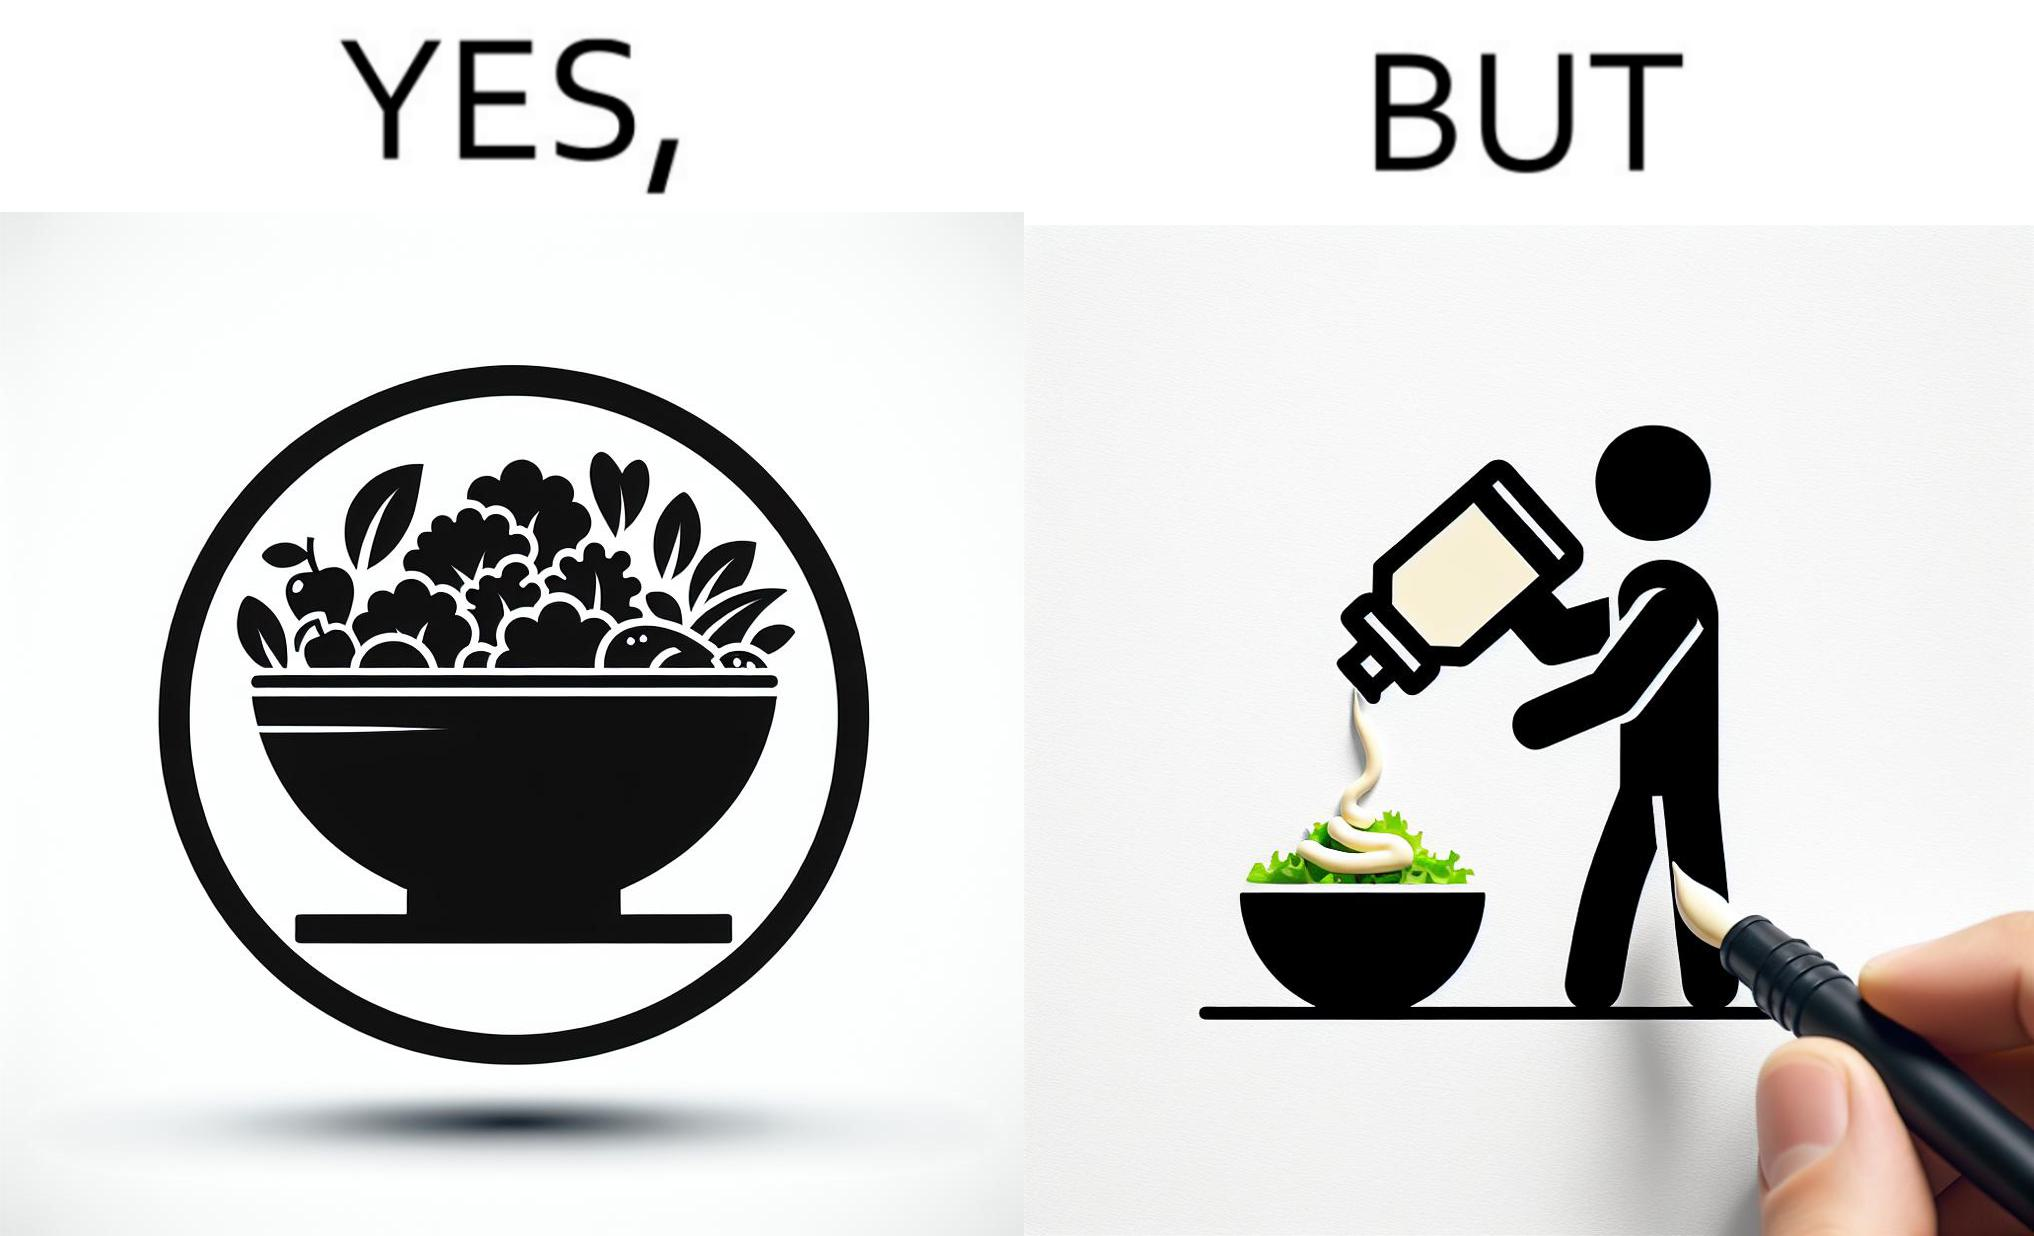What is shown in this image? The image is ironical, as salad in a bowl by itself is very healthy. However, when people have it with Mayonnaise sauce to improve the taste, it is not healthy anymore, and defeats the point of having nutrient-rich salad altogether. 